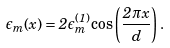<formula> <loc_0><loc_0><loc_500><loc_500>\epsilon _ { m } ( x ) = 2 \epsilon _ { m } ^ { ( 1 ) } \cos \left ( \frac { 2 \pi x } { d } \right ) .</formula> 